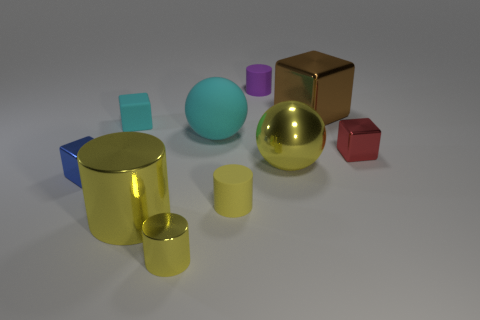Is the size of the blue metal block the same as the brown metallic thing?
Give a very brief answer. No. How many things are big yellow rubber cylinders or yellow metallic things?
Offer a terse response. 3. There is a cube that is in front of the big brown thing and right of the cyan block; what size is it?
Provide a short and direct response. Small. Is the number of matte objects that are in front of the small purple matte cylinder less than the number of matte cylinders?
Offer a very short reply. No. What shape is the small blue thing that is the same material as the brown thing?
Your answer should be very brief. Cube. Does the big metal thing that is behind the red shiny object have the same shape as the rubber object that is in front of the red cube?
Make the answer very short. No. Is the number of tiny purple cylinders behind the tiny purple cylinder less than the number of cyan matte things to the right of the yellow matte thing?
Keep it short and to the point. No. There is a big thing that is the same color as the big cylinder; what is its shape?
Keep it short and to the point. Sphere. How many other objects are the same size as the yellow matte object?
Provide a succinct answer. 5. Is the cyan thing that is to the right of the small metal cylinder made of the same material as the tiny purple object?
Offer a very short reply. Yes. 